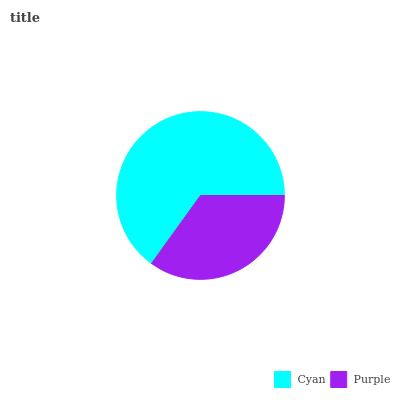Is Purple the minimum?
Answer yes or no. Yes. Is Cyan the maximum?
Answer yes or no. Yes. Is Purple the maximum?
Answer yes or no. No. Is Cyan greater than Purple?
Answer yes or no. Yes. Is Purple less than Cyan?
Answer yes or no. Yes. Is Purple greater than Cyan?
Answer yes or no. No. Is Cyan less than Purple?
Answer yes or no. No. Is Cyan the high median?
Answer yes or no. Yes. Is Purple the low median?
Answer yes or no. Yes. Is Purple the high median?
Answer yes or no. No. Is Cyan the low median?
Answer yes or no. No. 